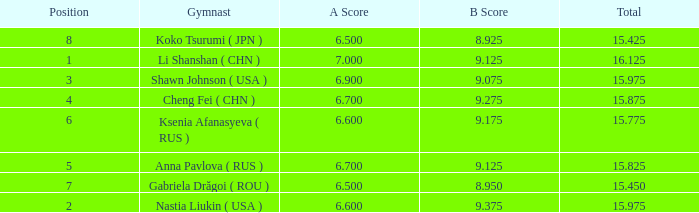What's the total that the position is less than 1? None. 